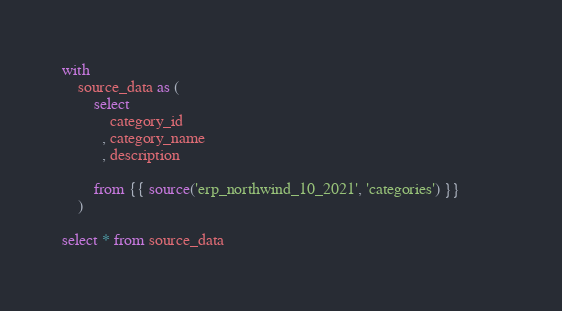Convert code to text. <code><loc_0><loc_0><loc_500><loc_500><_SQL_>with
    source_data as (
        select
            category_id
          , category_name
          , description                       

        from {{ source('erp_northwind_10_2021', 'categories') }}          
    )

select * from source_data</code> 